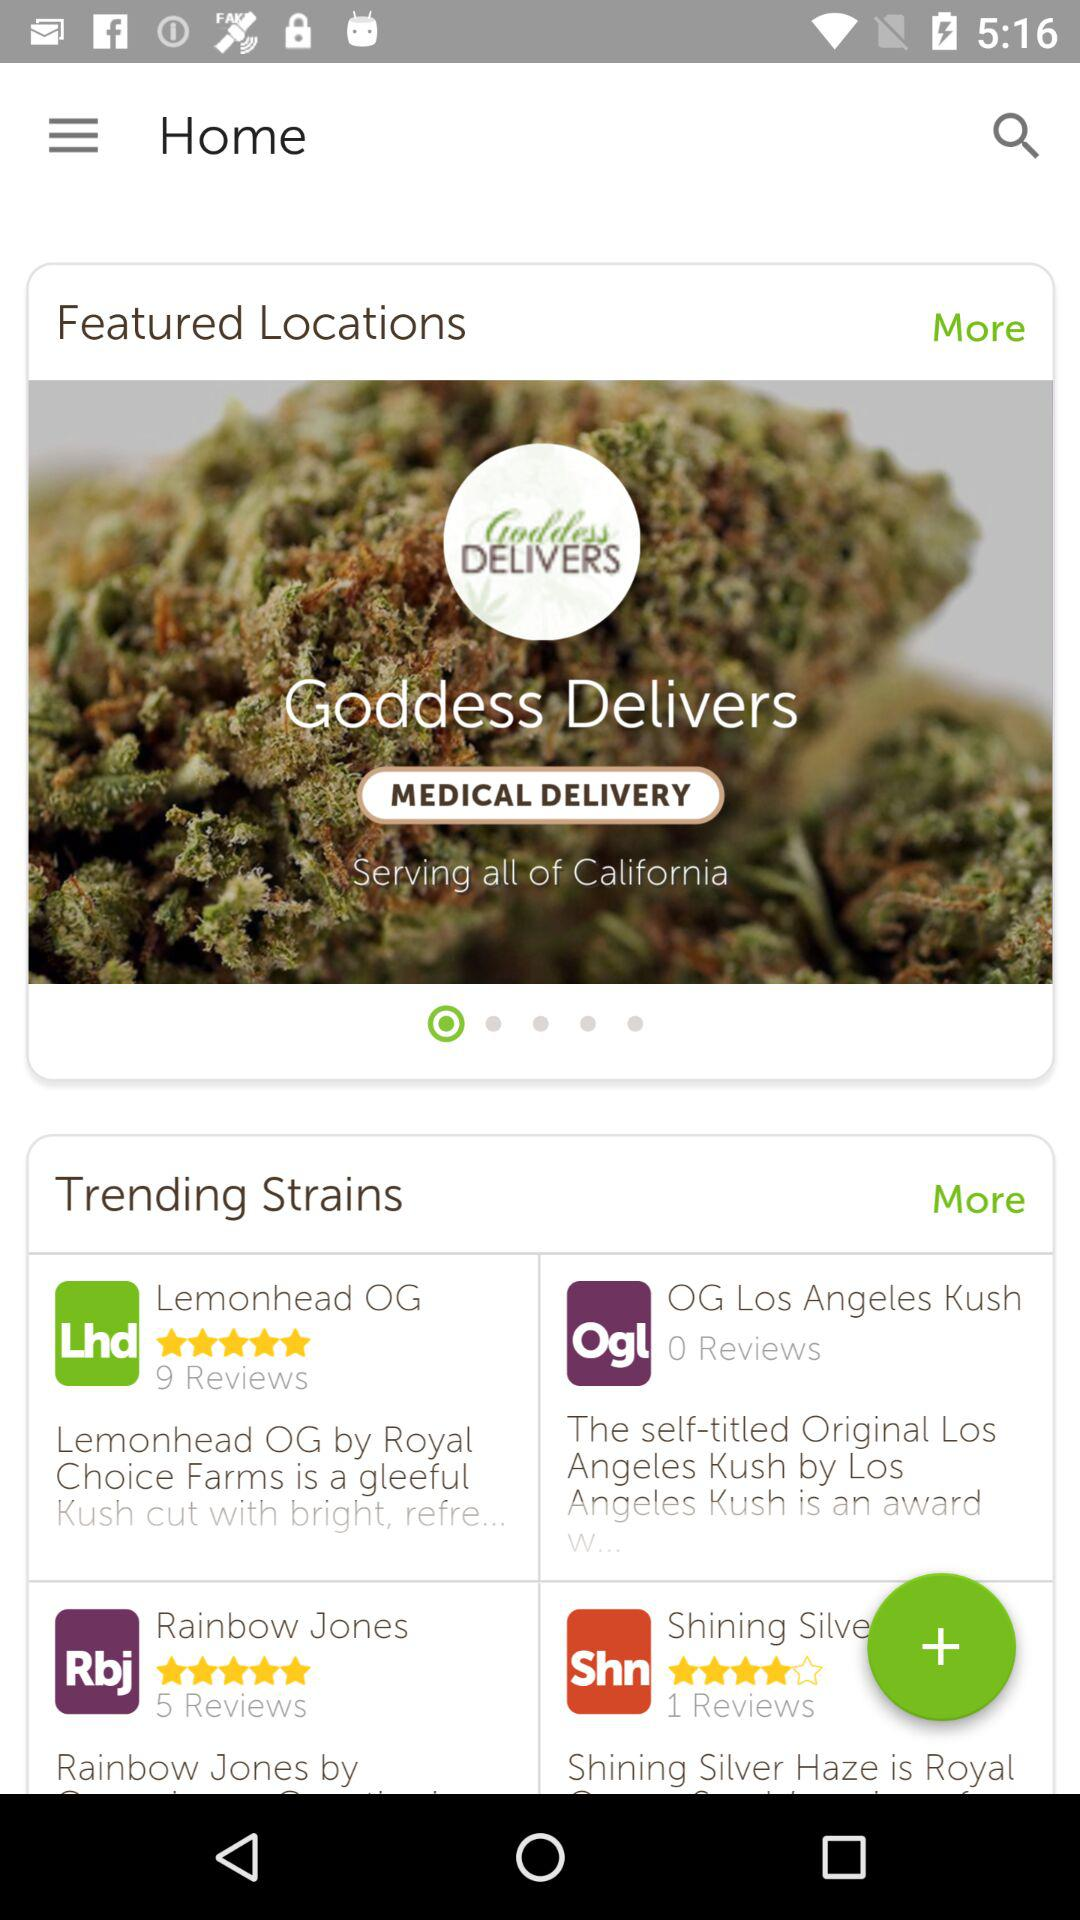In which country does "Goddess Deliver" provide services? "Goddess Delivers" provides services in all of California. 